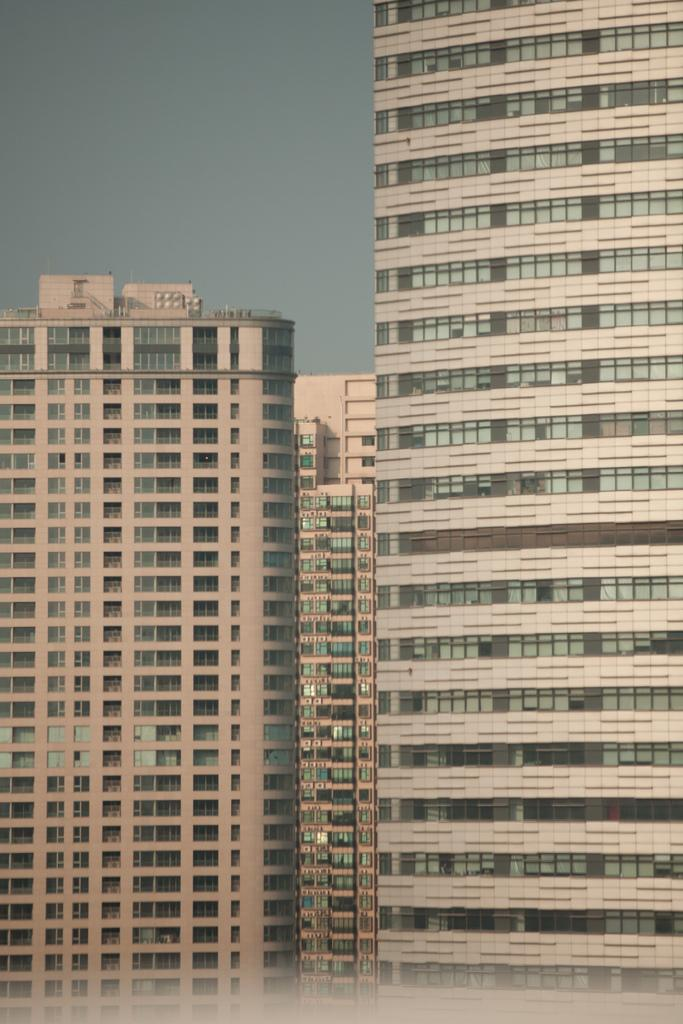What type of structures are present in the image? There are huge buildings in the image. What part of the natural environment is visible in the image? The sky is visible in the image. How many eyes can be seen on the buildings in the image? There are no eyes visible on the buildings in the image. What type of weather is depicted in the image during a rainstorm? There is no rainstorm depicted in the image; only the buildings and sky are visible. 